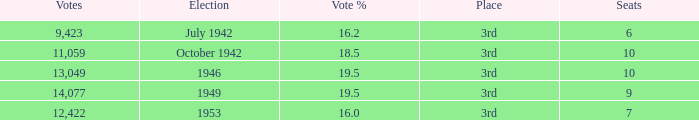Name the total number of seats for votes % more than 19.5 0.0. 